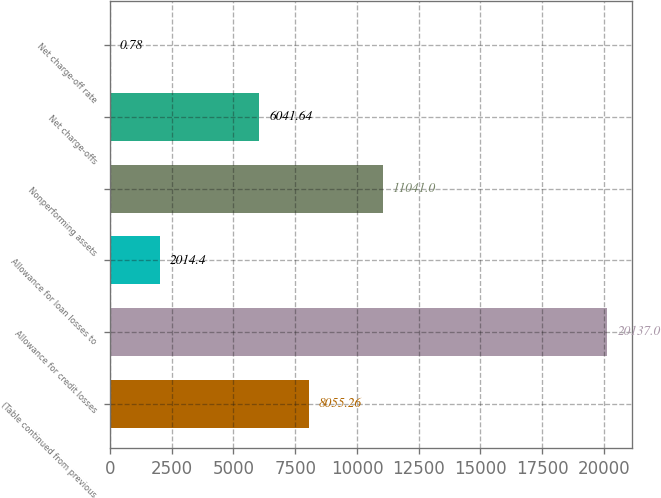Convert chart. <chart><loc_0><loc_0><loc_500><loc_500><bar_chart><fcel>(Table continued from previous<fcel>Allowance for credit losses<fcel>Allowance for loan losses to<fcel>Nonperforming assets<fcel>Net charge-offs<fcel>Net charge-off rate<nl><fcel>8055.26<fcel>20137<fcel>2014.4<fcel>11041<fcel>6041.64<fcel>0.78<nl></chart> 